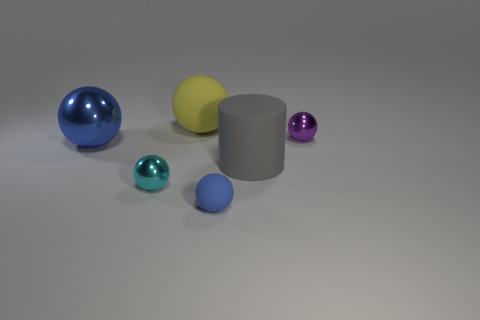Subtract all matte spheres. How many spheres are left? 3 Subtract all spheres. How many objects are left? 1 Add 3 tiny purple cylinders. How many objects exist? 9 Subtract 5 spheres. How many spheres are left? 0 Subtract all yellow balls. How many balls are left? 4 Subtract all brown balls. How many brown cylinders are left? 0 Subtract all small balls. Subtract all cyan spheres. How many objects are left? 2 Add 4 purple metal objects. How many purple metal objects are left? 5 Add 5 small gray spheres. How many small gray spheres exist? 5 Subtract 0 cyan blocks. How many objects are left? 6 